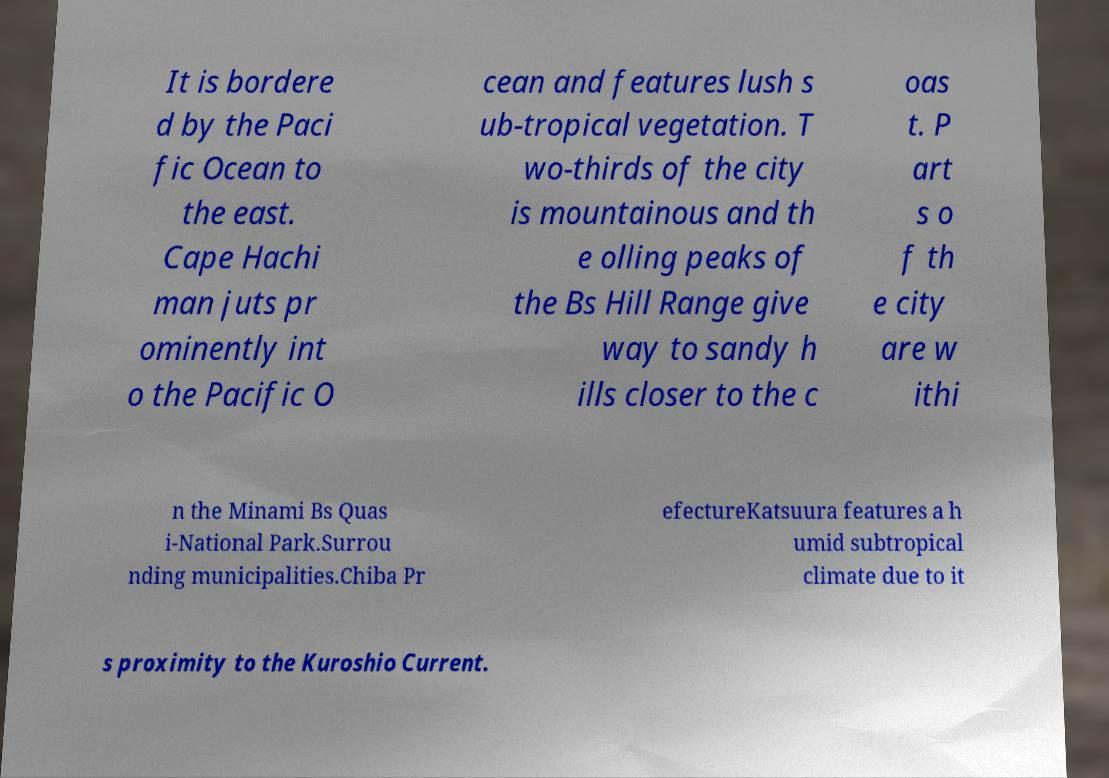There's text embedded in this image that I need extracted. Can you transcribe it verbatim? It is bordere d by the Paci fic Ocean to the east. Cape Hachi man juts pr ominently int o the Pacific O cean and features lush s ub-tropical vegetation. T wo-thirds of the city is mountainous and th e olling peaks of the Bs Hill Range give way to sandy h ills closer to the c oas t. P art s o f th e city are w ithi n the Minami Bs Quas i-National Park.Surrou nding municipalities.Chiba Pr efectureKatsuura features a h umid subtropical climate due to it s proximity to the Kuroshio Current. 